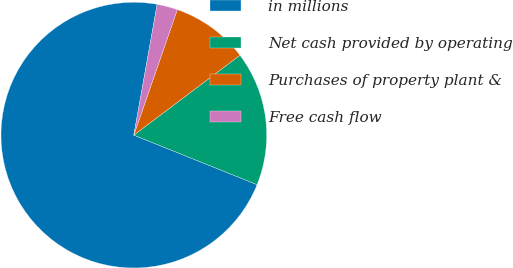<chart> <loc_0><loc_0><loc_500><loc_500><pie_chart><fcel>in millions<fcel>Net cash provided by operating<fcel>Purchases of property plant &<fcel>Free cash flow<nl><fcel>71.73%<fcel>16.35%<fcel>9.42%<fcel>2.5%<nl></chart> 